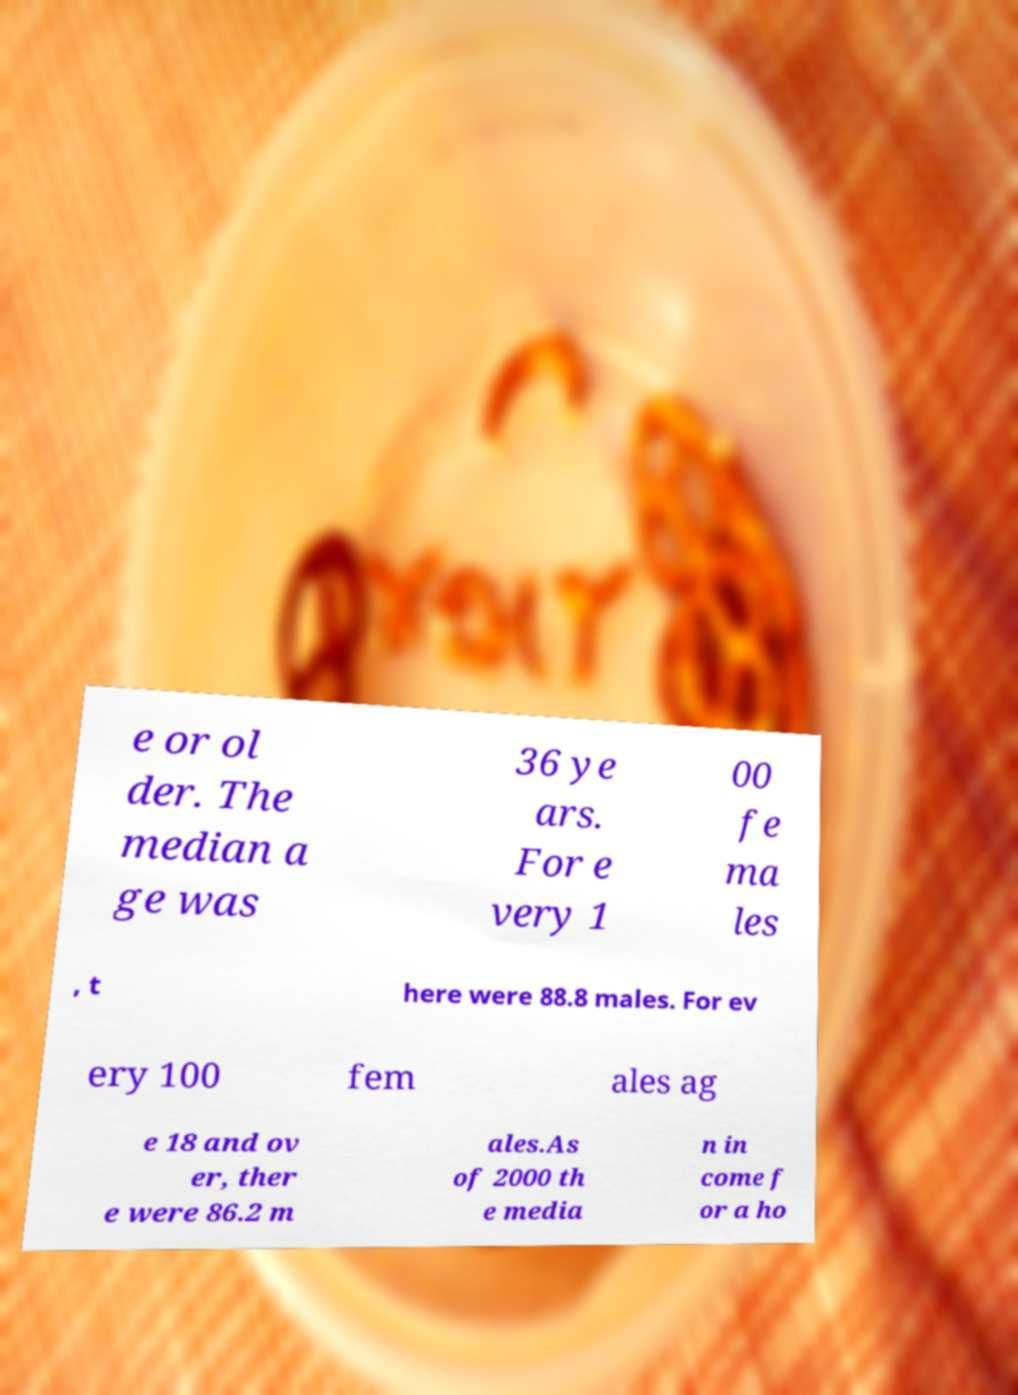Could you assist in decoding the text presented in this image and type it out clearly? e or ol der. The median a ge was 36 ye ars. For e very 1 00 fe ma les , t here were 88.8 males. For ev ery 100 fem ales ag e 18 and ov er, ther e were 86.2 m ales.As of 2000 th e media n in come f or a ho 